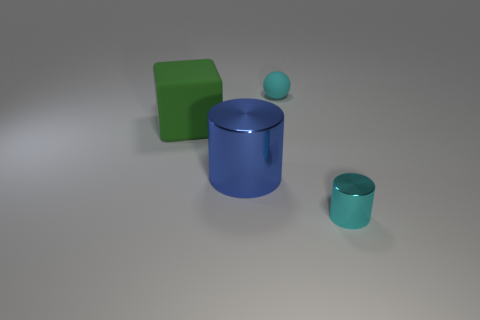How many other objects are there of the same material as the green thing?
Make the answer very short. 1. What shape is the thing that is both right of the green block and behind the big shiny cylinder?
Provide a short and direct response. Sphere. Do the cyan matte ball that is on the right side of the large green thing and the matte thing left of the large blue object have the same size?
Offer a terse response. No. The big green object that is made of the same material as the small sphere is what shape?
Your answer should be very brief. Cube. Is there any other thing that is the same shape as the cyan rubber object?
Ensure brevity in your answer.  No. There is a large object to the left of the metal object that is behind the tiny cyan object that is in front of the blue object; what color is it?
Make the answer very short. Green. Is the number of small objects that are in front of the large metal cylinder less than the number of tiny shiny things behind the cyan metal cylinder?
Keep it short and to the point. No. Does the small cyan metallic object have the same shape as the large blue metal object?
Give a very brief answer. Yes. What number of green matte cubes are the same size as the cyan metal thing?
Keep it short and to the point. 0. Is the number of big blue cylinders in front of the large blue cylinder less than the number of cyan matte spheres?
Make the answer very short. Yes. 